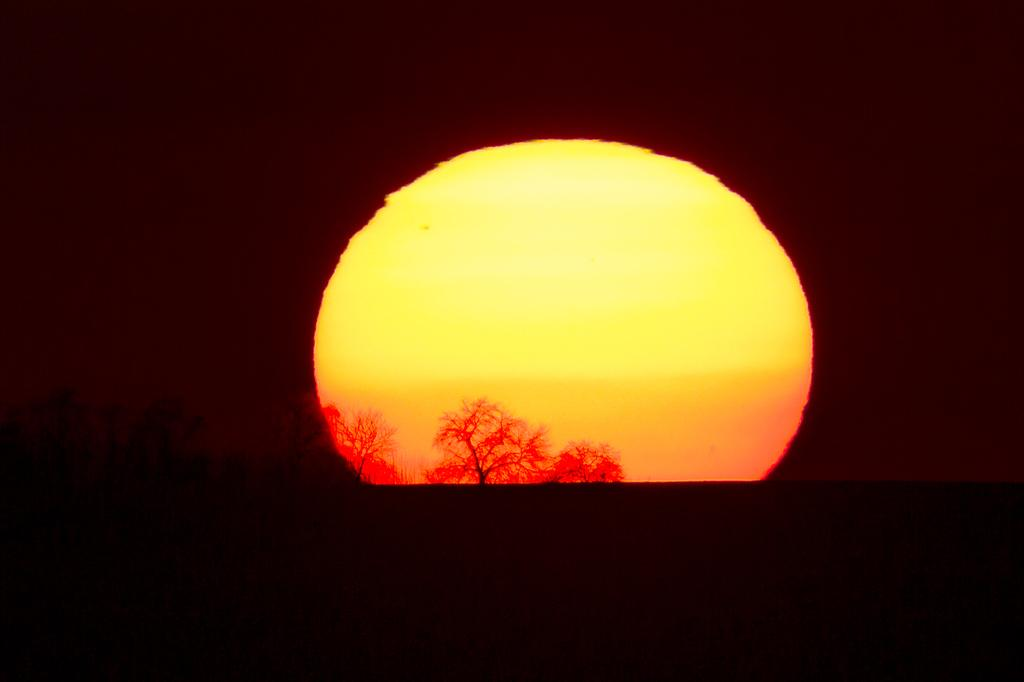What is the main subject of the image? The sun is in the center of the image. What can be seen in the foreground of the image? There are trees in the foreground of the image. How would you describe the edges of the image? The edges of the image are dark. What type of error can be seen in the image? There is no error present in the image; it is a clear image of the sun and trees. What role does the fireman play in the image? There is no fireman present in the image. How does the image demonstrate acoustics? The image does not demonstrate acoustics, as it is a visual representation of the sun and trees. 